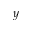<formula> <loc_0><loc_0><loc_500><loc_500>y</formula> 